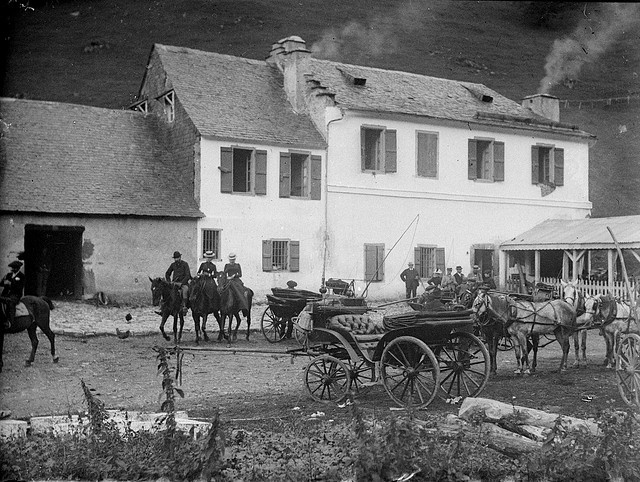Describe the objects in this image and their specific colors. I can see horse in black, gray, darkgray, and lightgray tones, horse in black, gray, and lightgray tones, horse in black, gray, darkgray, and lightgray tones, horse in black, gray, darkgray, and lightgray tones, and horse in black, gray, darkgray, and lightgray tones in this image. 